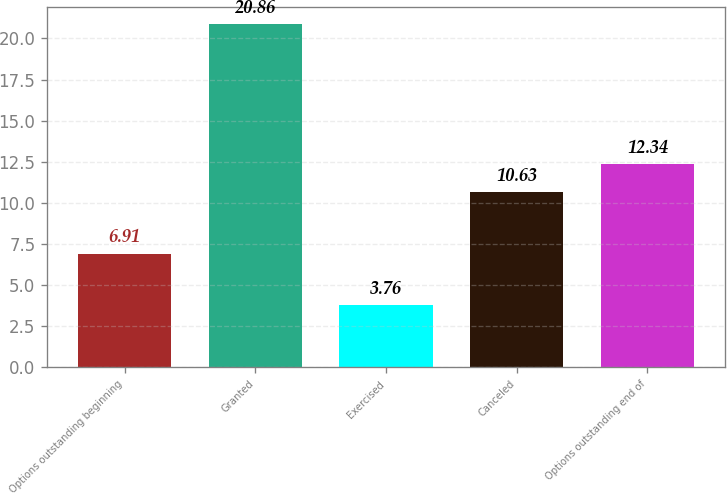<chart> <loc_0><loc_0><loc_500><loc_500><bar_chart><fcel>Options outstanding beginning<fcel>Granted<fcel>Exercised<fcel>Canceled<fcel>Options outstanding end of<nl><fcel>6.91<fcel>20.86<fcel>3.76<fcel>10.63<fcel>12.34<nl></chart> 